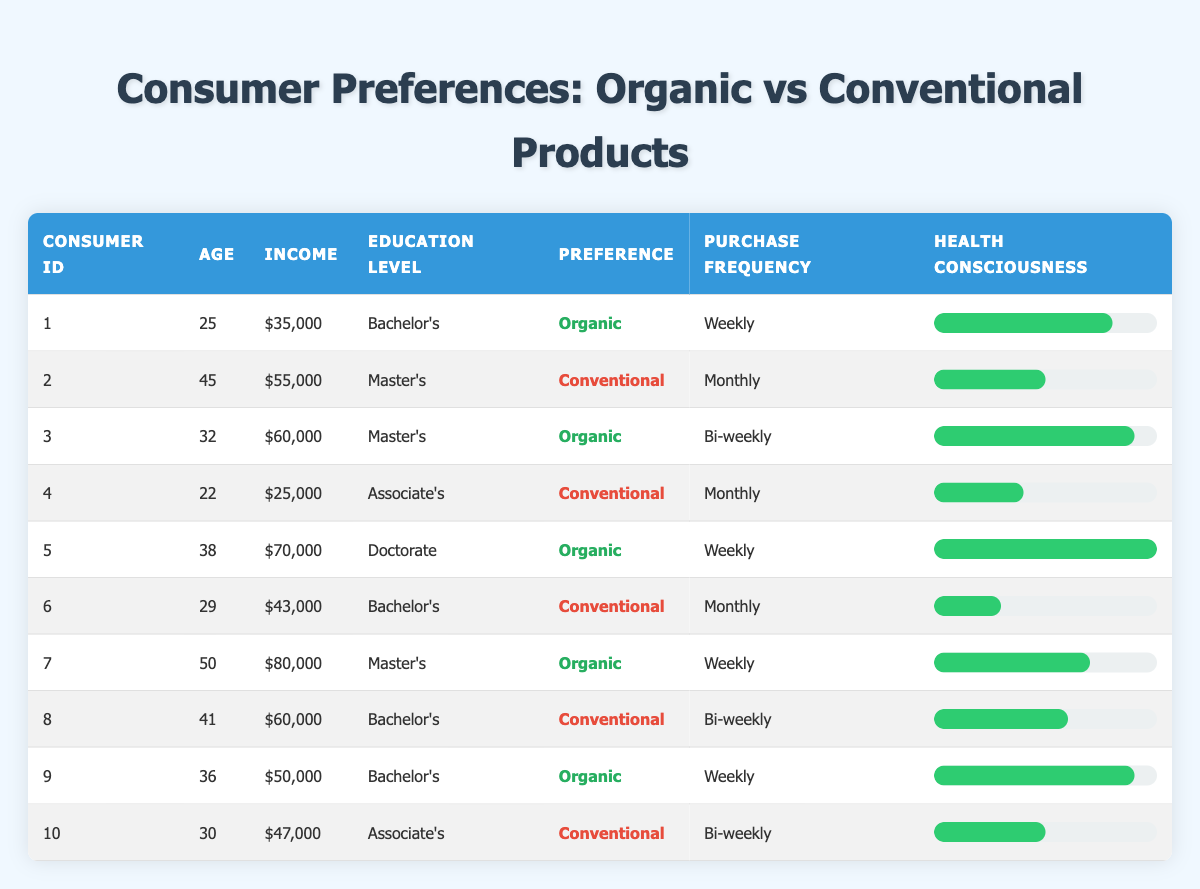What is the age of the consumer who prefers organic products with the highest health consciousness? The consumer ID 5 prefers organic products and has the highest health consciousness rating of 10. Their age is 38.
Answer: 38 What is the average income of consumers who prefer conventional products? The consumers who prefer conventional products are IDs 2, 4, 6, 8, and 10. Their incomes are 55000, 25000, 43000, 60000, and 47000. Summing these gives 55000 + 25000 + 43000 + 60000 + 47000 = 230000. The average income is 230000 / 5 = 46000.
Answer: 46000 Is there a consumer who is both health-conscious and makes weekly purchases of organic products? Consumers ID 1, 5, 7, and 9 prefer organic products and purchase them weekly. Their health consciousness ratings are 8, 10, 7, and 9, which all indicate health-consciousness. Therefore, the answer is yes.
Answer: Yes How many consumers hold a Doctorate degree and prefer organic products? The data shows that Consumer ID 5 is the only one holding a Doctorate degree and they prefer organic products. Thus, there is only one such consumer.
Answer: 1 What percentage of consumers prefer organic products compared to those who prefer conventional products? There are 6 consumers who prefer organic products (IDs 1, 3, 5, 7, 9) and 4 consumers who prefer conventional products (IDs 2, 4, 6, 8, 10). The percentage of organic preference is calculated as (6 / 10) * 100 = 60%.
Answer: 60% Which consumer has the lowest income and what is their preference? Consumer ID 4 has the lowest income of 25000 and their preference is for conventional products.
Answer: Conventional How many consumers have a Master's degree and prefer organic products? The data reveals that Consumers ID 3 and 7 are the only ones with a Master's degree who prefer organic products. Therefore, the count is two.
Answer: 2 What is the health consciousness score of the consumer who is aged 50 and prefers organic products? Consumer ID 7 is aged 50 and prefers organic products, with a health consciousness score of 7.
Answer: 7 How many consumers purchase organic products weekly? Reviewing the purchase frequency, Consumers ID 1, 5, 7, and 9 purchase organic products weekly, totaling four consumers.
Answer: 4 